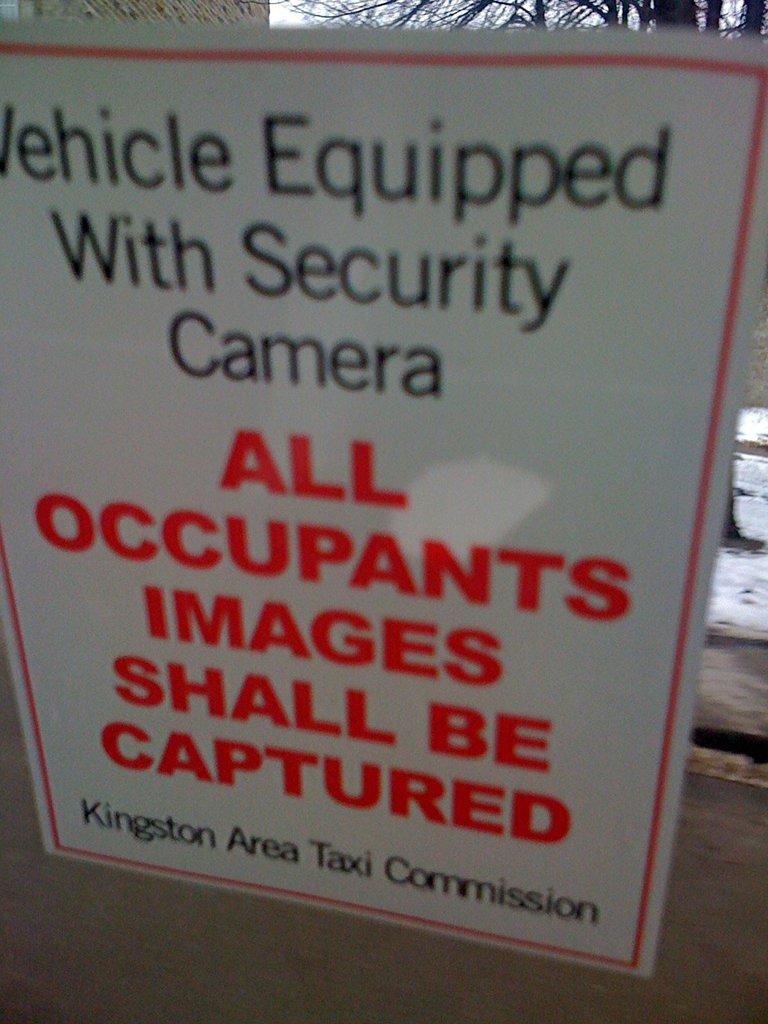What shall be captured?
Ensure brevity in your answer.  All occupants images. What is the commission name?
Keep it short and to the point. Kingston area taxi commission. 